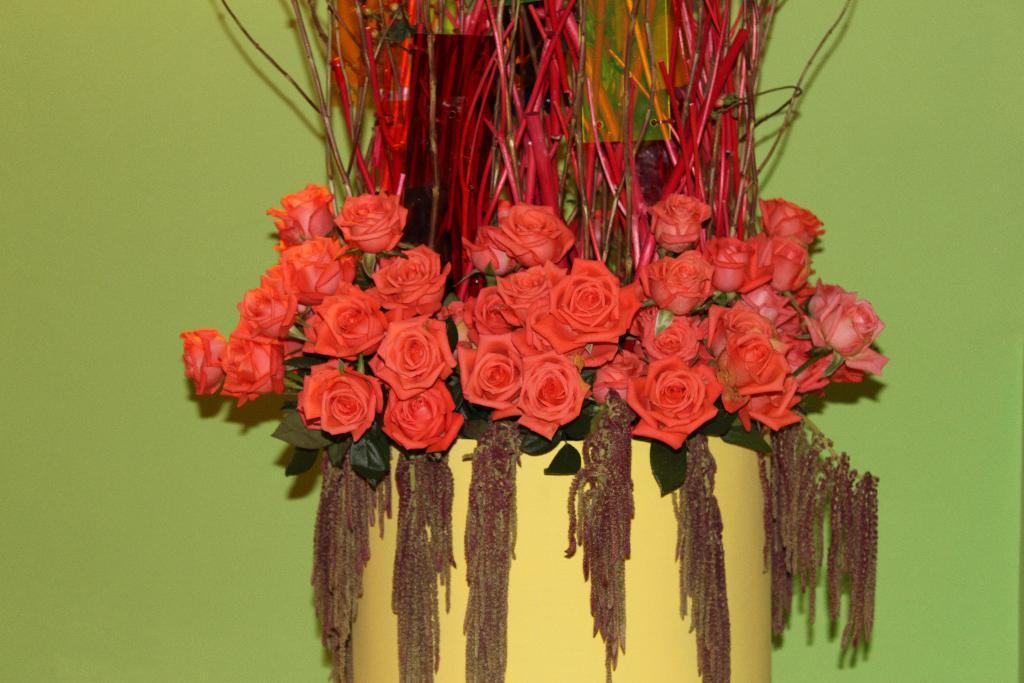Can you describe this image briefly? In this picture, it seems to be a flower vase in the center of the image. 